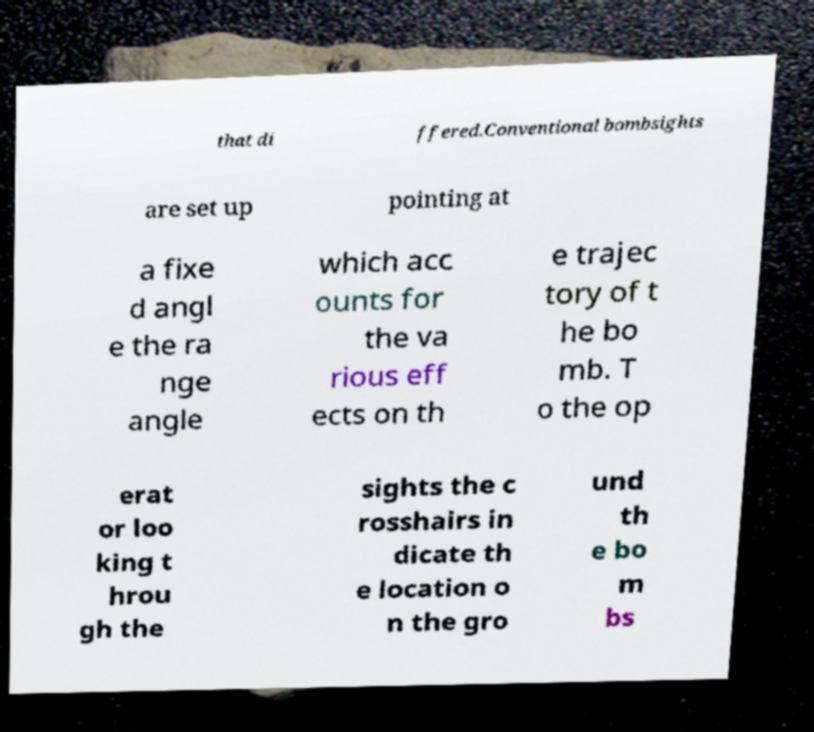I need the written content from this picture converted into text. Can you do that? that di ffered.Conventional bombsights are set up pointing at a fixe d angl e the ra nge angle which acc ounts for the va rious eff ects on th e trajec tory of t he bo mb. T o the op erat or loo king t hrou gh the sights the c rosshairs in dicate th e location o n the gro und th e bo m bs 